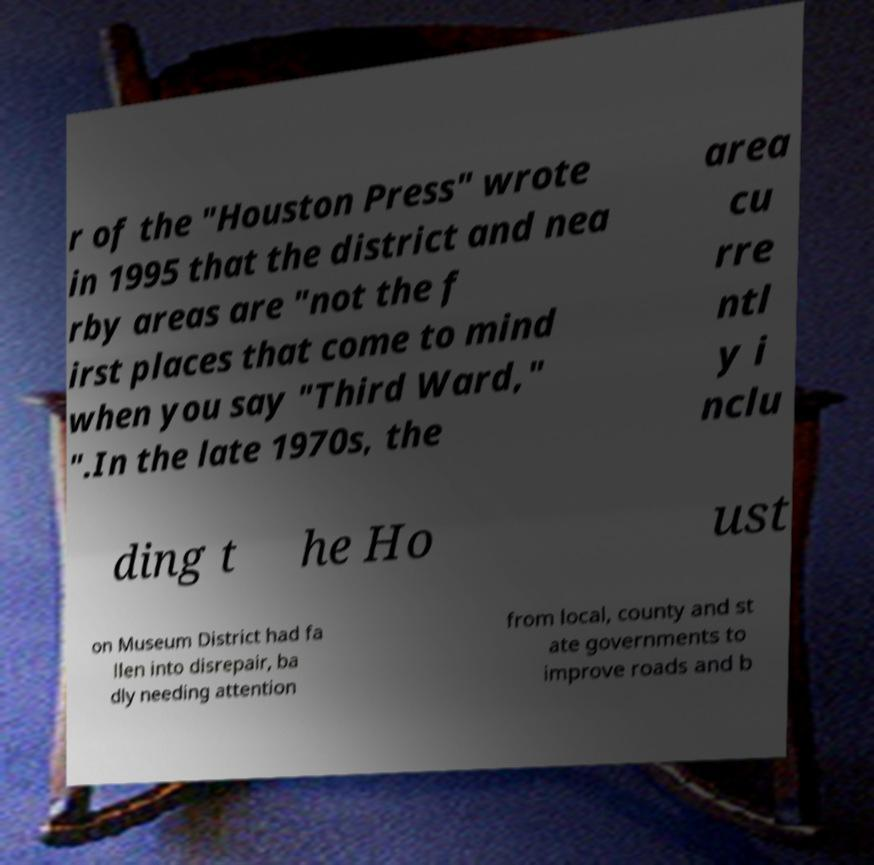I need the written content from this picture converted into text. Can you do that? r of the "Houston Press" wrote in 1995 that the district and nea rby areas are "not the f irst places that come to mind when you say "Third Ward," ".In the late 1970s, the area cu rre ntl y i nclu ding t he Ho ust on Museum District had fa llen into disrepair, ba dly needing attention from local, county and st ate governments to improve roads and b 